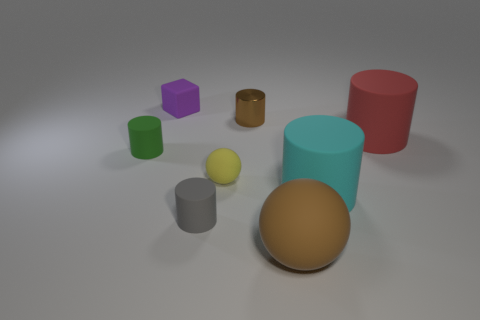Is there anything else that has the same material as the tiny brown cylinder?
Give a very brief answer. No. What material is the large red thing that is the same shape as the green rubber thing?
Your answer should be very brief. Rubber. How many other things are there of the same material as the red thing?
Offer a terse response. 6. Is the number of yellow rubber balls less than the number of big cylinders?
Ensure brevity in your answer.  Yes. Are the large red thing and the cylinder that is to the left of the small purple matte object made of the same material?
Ensure brevity in your answer.  Yes. What shape is the brown thing behind the green object?
Offer a very short reply. Cylinder. Is there anything else of the same color as the tiny rubber cube?
Provide a short and direct response. No. Are there fewer small purple objects behind the small purple thing than small green rubber objects?
Offer a terse response. Yes. How many brown matte balls have the same size as the yellow rubber object?
Your answer should be very brief. 0. There is a big object that is the same color as the small metal cylinder; what shape is it?
Offer a very short reply. Sphere. 